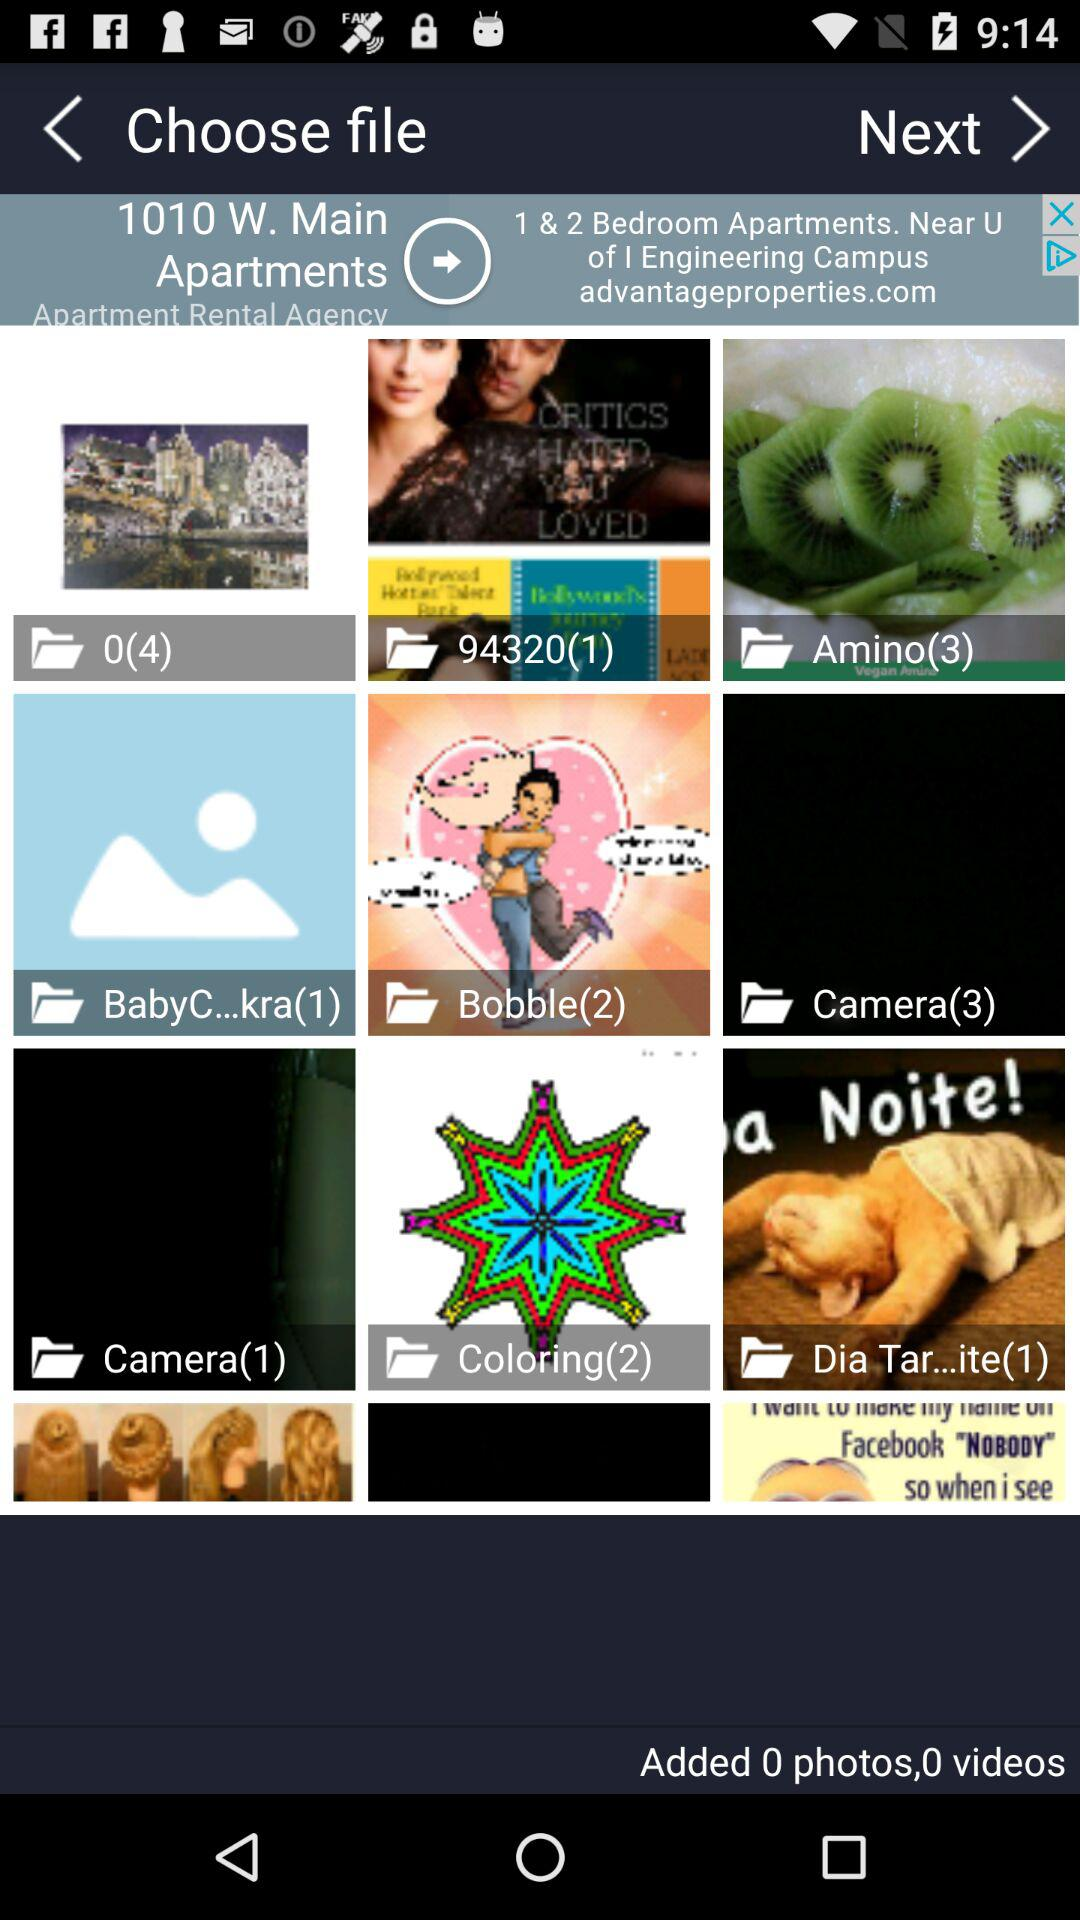What is the number of added photos and videos? The number of added photos and videos is 0. 